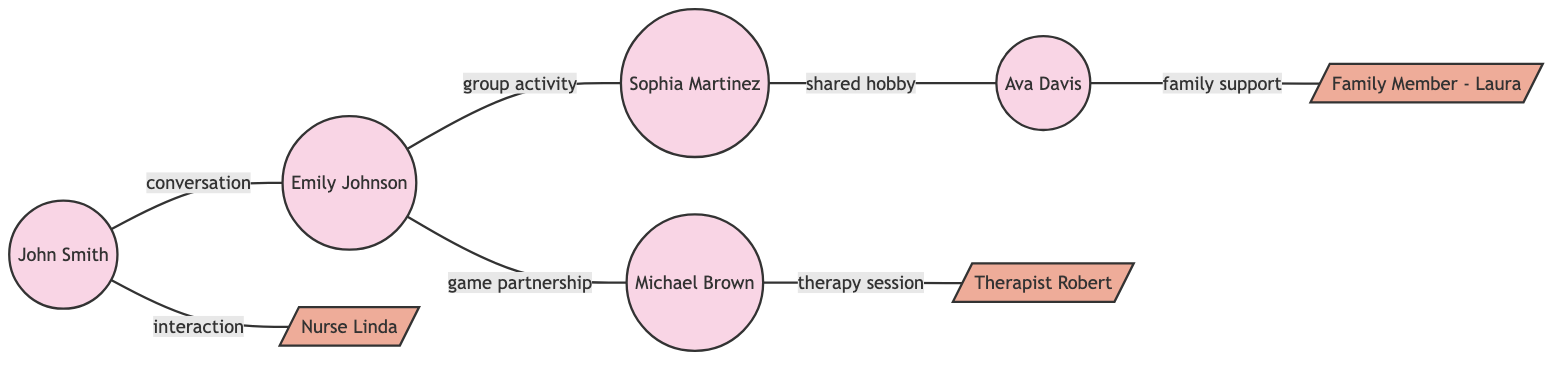What is the total number of patients represented in the diagram? To find the total number of patients, count the nodes that are labeled as patients. The nodes are John Smith, Emily Johnson, Michael Brown, Sophia Martinez, and Ava Davis, which totals to 5 patients.
Answer: 5 Who has a therapy session with Michael Brown? The edge connecting Michael Brown to Therapist Robert indicates that Michael has a therapy session with him.
Answer: Therapist Robert What relationship does John Smith have with Emily Johnson? The edge labeled "conversation" connects John Smith and Emily Johnson, indicating their relationship involves conversation.
Answer: conversation How many support members are represented in the diagram? Count the nodes that are labeled as support members. The support members are Nurse Linda, Therapist Robert, and Family Member - Laura, which totals to 3 support members.
Answer: 3 Which patient shares a hobby with Ava Davis? The edge labeled "shared hobby" connects Sophia Martinez and Ava Davis, indicating they share a hobby together.
Answer: Sophia Martinez How many unique interactions are recorded in the diagram? To find the total unique interactions, count the edges, which represent interactions. There are 6 edges in the diagram indicating 6 unique interactions.
Answer: 6 Is there a direct connection between Emily Johnson and Sophia Martinez? There is no direct edge connecting Emily Johnson to Sophia Martinez in the diagram, meaning they do not have a direct relationship.
Answer: No What activity links Emily Johnson and Michael Brown? The edge labeled "game partnership" indicates the specific activity linking Emily Johnson and Michael Brown.
Answer: game partnership Which patient has family support, and who is the family member? The edge labeled "family support" connects Ava Davis to Family Member - Laura, indicating that Ava Davis receives family support from Laura.
Answer: Ava Davis, Family Member - Laura 